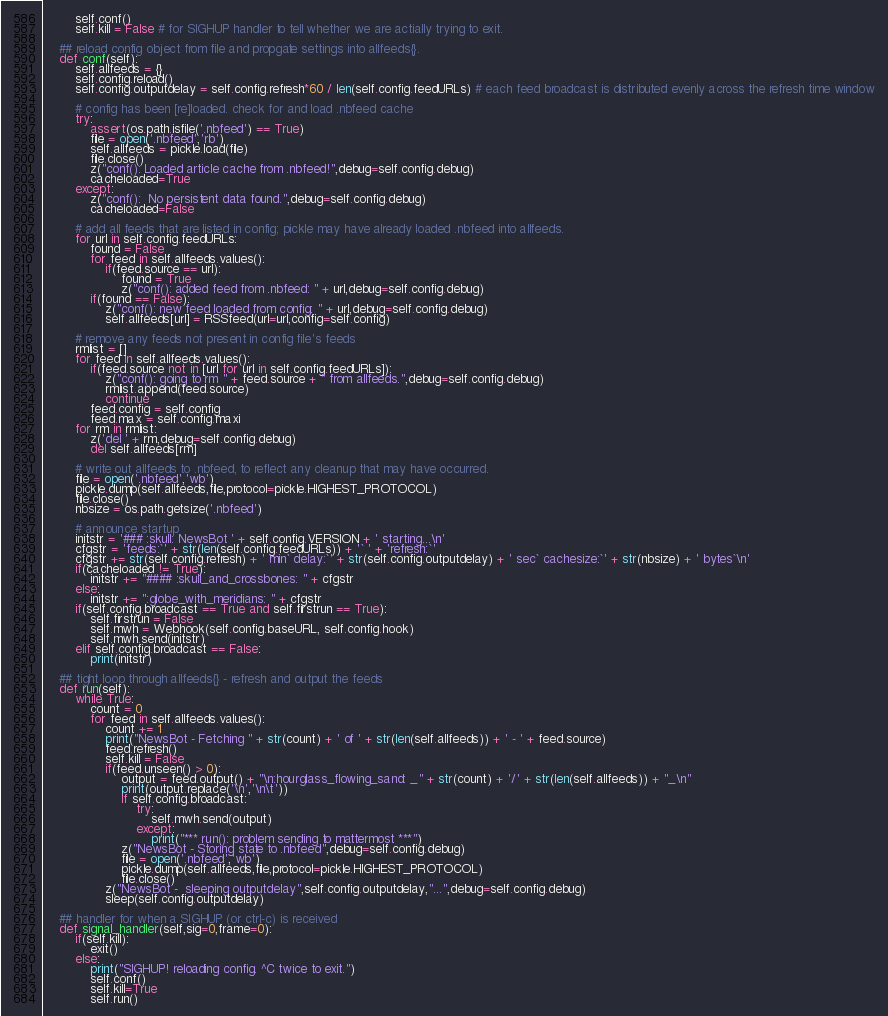<code> <loc_0><loc_0><loc_500><loc_500><_Python_>        self.conf()
        self.kill = False # for SIGHUP handler to tell whether we are actially trying to exit.

    ## reload config object from file and propgate settings into allfeeds{}.
    def conf(self):
        self.allfeeds = {}
        self.config.reload()
        self.config.outputdelay = self.config.refresh*60 / len(self.config.feedURLs) # each feed broadcast is distributed evenly across the refresh time window

        # config has been [re]loaded. check for and load .nbfeed cache
        try:
            assert(os.path.isfile('.nbfeed') == True)
            file = open('.nbfeed','rb')
            self.allfeeds = pickle.load(file)
            file.close()
            z("conf(): Loaded article cache from .nbfeed!",debug=self.config.debug)
            cacheloaded=True
        except:
            z("conf():  No persistent data found.",debug=self.config.debug)
            cacheloaded=False

        # add all feeds that are listed in config; pickle may have already loaded .nbfeed into allfeeds.
        for url in self.config.feedURLs:
            found = False
            for feed in self.allfeeds.values():
                if(feed.source == url):
                    found = True
                    z("conf(): added feed from .nbfeed: " + url,debug=self.config.debug)
            if(found == False):
                z("conf(): new feed loaded from config: " + url,debug=self.config.debug)
                self.allfeeds[url] = RSSfeed(url=url,config=self.config)

        # remove any feeds not present in config file's feeds
        rmlist = []
        for feed in self.allfeeds.values():
            if(feed.source not in [url for url in self.config.feedURLs]):
                z("conf(): going to rm " + feed.source + " from allfeeds.",debug=self.config.debug)
                rmlist.append(feed.source)
                continue
            feed.config = self.config
            feed.max = self.config.maxi
        for rm in rmlist:
            z('del ' + rm,debug=self.config.debug) 
            del self.allfeeds[rm]

        # write out allfeeds to .nbfeed, to reflect any cleanup that may have occurred.
        file = open('.nbfeed','wb')
        pickle.dump(self.allfeeds,file,protocol=pickle.HIGHEST_PROTOCOL)
        file.close()
        nbsize = os.path.getsize('.nbfeed')

        # announce startup
        initstr = '### :skull: NewsBot ' + self.config.VERSION + ' starting...\n'
        cfgstr = 'feeds:`' + str(len(self.config.feedURLs)) + '` ' + 'refresh:`'
        cfgstr += str(self.config.refresh) + ' min` delay:`' + str(self.config.outputdelay) + ' sec` cachesize:`' + str(nbsize) + ' bytes`\n'
        if(cacheloaded != True):
            initstr += "#### :skull_and_crossbones: " + cfgstr
        else:
            initstr += ":globe_with_meridians: " + cfgstr
        if(self.config.broadcast == True and self.firstrun == True):
            self.firstrun = False
            self.mwh = Webhook(self.config.baseURL, self.config.hook)
            self.mwh.send(initstr)
        elif self.config.broadcast == False:
            print(initstr)

    ## tight loop through allfeeds{} - refresh and output the feeds
    def run(self):
        while True:
            count = 0
            for feed in self.allfeeds.values():
                count += 1
                print("NewsBot - Fetching " + str(count) + ' of ' + str(len(self.allfeeds)) + ' - ' + feed.source)
                feed.refresh()
                self.kill = False
                if(feed.unseen() > 0):
                    output = feed.output() + "\n:hourglass_flowing_sand: _" + str(count) + '/' + str(len(self.allfeeds)) + "_\n"
                    print(output.replace('\n','\n\t'))
                    if self.config.broadcast:
                        try:
                            self.mwh.send(output)
                        except:
                            print("*** run(): problem sending to mattermost ***")
                    z("NewsBot - Storing state to .nbfeed",debug=self.config.debug)
                    file = open('.nbfeed','wb')
                    pickle.dump(self.allfeeds,file,protocol=pickle.HIGHEST_PROTOCOL)
                    file.close()
                z("NewsBot -  sleeping outputdelay",self.config.outputdelay,"...",debug=self.config.debug)
                sleep(self.config.outputdelay)

    ## handler for when a SIGHUP (or ctrl-c) is received
    def signal_handler(self,sig=0,frame=0):
        if(self.kill):
            exit()
        else:
            print("SIGHUP! reloading config. ^C twice to exit.")
            self.conf()
            self.kill=True
            self.run()
</code> 